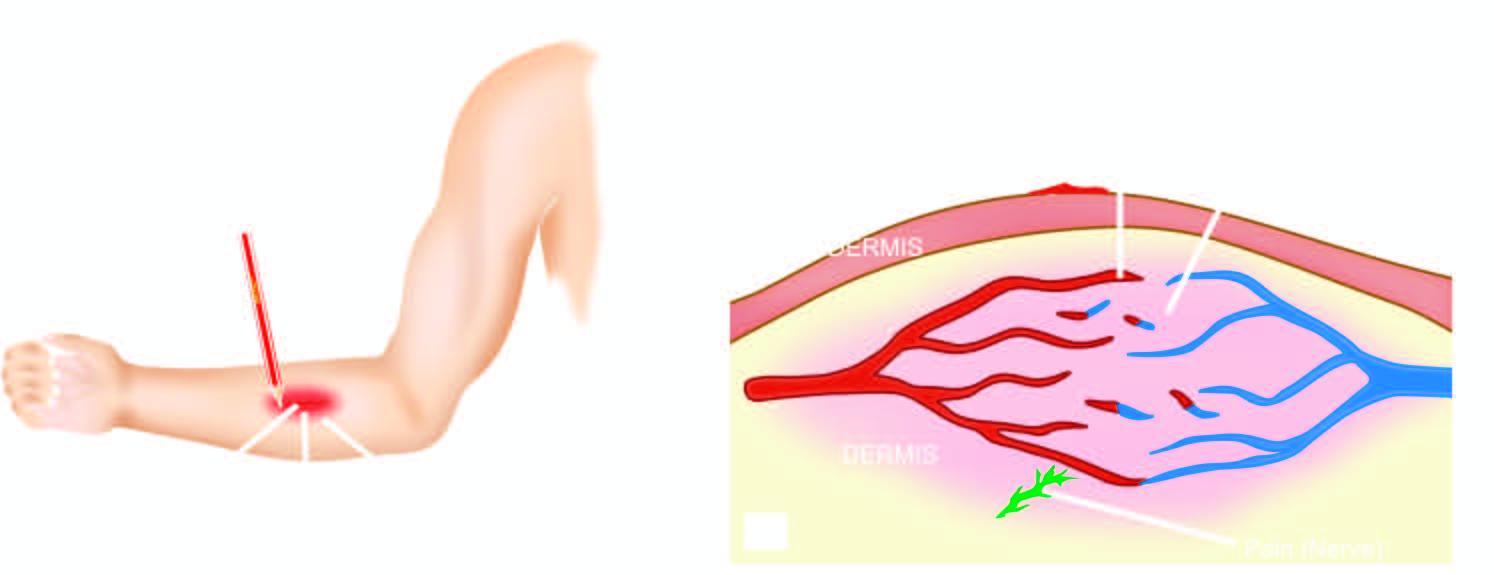s necrosis elicited by firm stroking of skin of forearm with a pencil?
Answer the question using a single word or phrase. No 